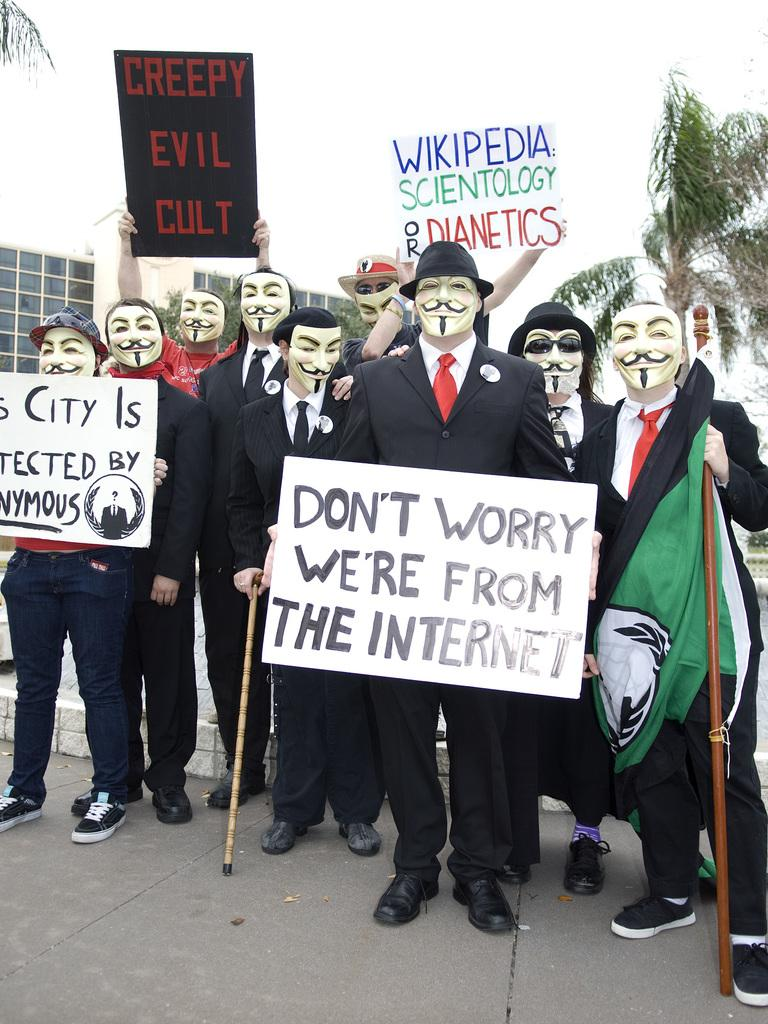<image>
Provide a brief description of the given image. the word worry is on a white sign someone is holding 